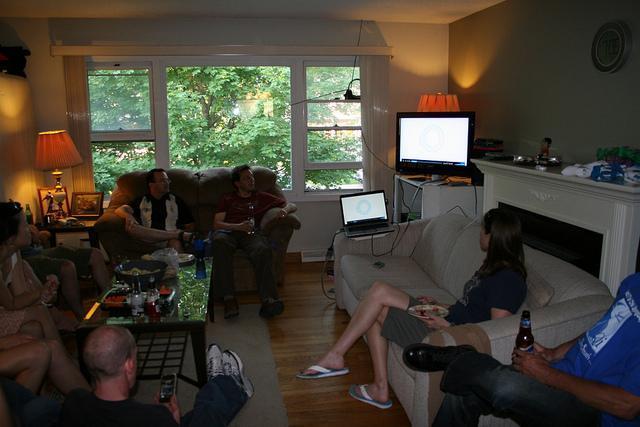How many people are visible?
Give a very brief answer. 8. How many couches are in the picture?
Give a very brief answer. 2. 